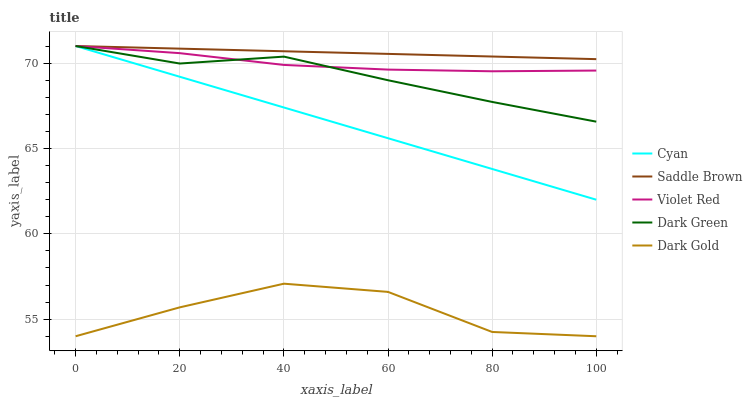Does Dark Gold have the minimum area under the curve?
Answer yes or no. Yes. Does Saddle Brown have the maximum area under the curve?
Answer yes or no. Yes. Does Violet Red have the minimum area under the curve?
Answer yes or no. No. Does Violet Red have the maximum area under the curve?
Answer yes or no. No. Is Cyan the smoothest?
Answer yes or no. Yes. Is Dark Gold the roughest?
Answer yes or no. Yes. Is Violet Red the smoothest?
Answer yes or no. No. Is Violet Red the roughest?
Answer yes or no. No. Does Dark Gold have the lowest value?
Answer yes or no. Yes. Does Violet Red have the lowest value?
Answer yes or no. No. Does Dark Green have the highest value?
Answer yes or no. Yes. Does Violet Red have the highest value?
Answer yes or no. No. Is Dark Gold less than Dark Green?
Answer yes or no. Yes. Is Saddle Brown greater than Violet Red?
Answer yes or no. Yes. Does Violet Red intersect Dark Green?
Answer yes or no. Yes. Is Violet Red less than Dark Green?
Answer yes or no. No. Is Violet Red greater than Dark Green?
Answer yes or no. No. Does Dark Gold intersect Dark Green?
Answer yes or no. No. 